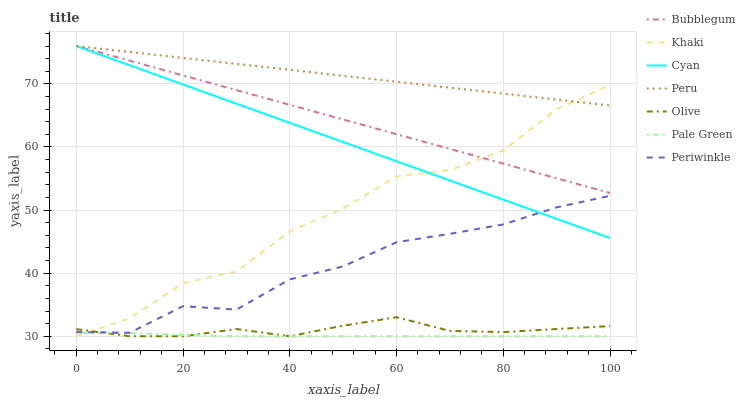Does Pale Green have the minimum area under the curve?
Answer yes or no. Yes. Does Peru have the maximum area under the curve?
Answer yes or no. Yes. Does Bubblegum have the minimum area under the curve?
Answer yes or no. No. Does Bubblegum have the maximum area under the curve?
Answer yes or no. No. Is Cyan the smoothest?
Answer yes or no. Yes. Is Khaki the roughest?
Answer yes or no. Yes. Is Bubblegum the smoothest?
Answer yes or no. No. Is Bubblegum the roughest?
Answer yes or no. No. Does Khaki have the lowest value?
Answer yes or no. Yes. Does Bubblegum have the lowest value?
Answer yes or no. No. Does Cyan have the highest value?
Answer yes or no. Yes. Does Pale Green have the highest value?
Answer yes or no. No. Is Pale Green less than Bubblegum?
Answer yes or no. Yes. Is Cyan greater than Olive?
Answer yes or no. Yes. Does Khaki intersect Pale Green?
Answer yes or no. Yes. Is Khaki less than Pale Green?
Answer yes or no. No. Is Khaki greater than Pale Green?
Answer yes or no. No. Does Pale Green intersect Bubblegum?
Answer yes or no. No. 